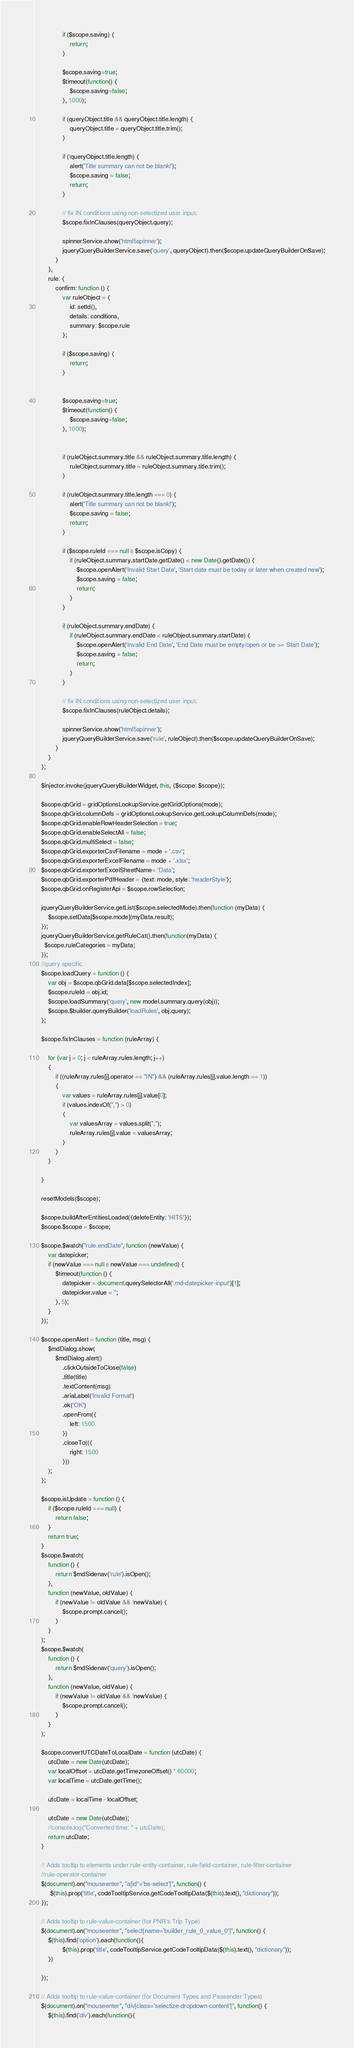<code> <loc_0><loc_0><loc_500><loc_500><_JavaScript_>
                if ($scope.saving) {
                    return;
                }

                $scope.saving=true;
                $timeout(function() {
                    $scope.saving=false;
                }, 1000);
               
                if (queryObject.title && queryObject.title.length) {
                    queryObject.title = queryObject.title.trim();
                }

                if (!queryObject.title.length) {
                    alert('Title summary can not be blank!');
                    $scope.saving = false;
                    return;
                }
                
                // fix IN conditions using non-selectized user input.
                $scope.fixInClauses(queryObject.query);

                spinnerService.show('html5spinner');
                jqueryQueryBuilderService.save('query', queryObject).then($scope.updateQueryBuilderOnSave);
            }
        },
        rule: {
            confirm: function () {
                var ruleObject = {
                    id: setId(),
                    details: conditions,
                    summary: $scope.rule
                };

                if ($scope.saving) {
                    return;
                }
                
              
                $scope.saving=true;
                $timeout(function() {
                    $scope.saving=false;
                }, 1000);


                if (ruleObject.summary.title && ruleObject.summary.title.length) {
                    ruleObject.summary.title = ruleObject.summary.title.trim();
                }

                if (ruleObject.summary.title.length === 0) {
                    alert('Title summary can not be blank!');
                    $scope.saving = false;
                    return;
                }

                if ($scope.ruleId === null || $scope.isCopy) {
                    if (ruleObject.summary.startDate.getDate() < new Date().getDate()) {
                        $scope.openAlert('Invalid Start Date', 'Start date must be today or later when created new');
                        $scope.saving = false;
                        return;
                    }
                }

                if (ruleObject.summary.endDate) {
                    if (ruleObject.summary.endDate < ruleObject.summary.startDate) {
                        $scope.openAlert('Invalid End Date', 'End Date must be empty/open or be >= Start Date');
                        $scope.saving = false;
                        return;
                    }
                }
                
                // fix IN conditions using non-selectized user input.
                $scope.fixInClauses(ruleObject.details);
 
                spinnerService.show('html5spinner');
                jqueryQueryBuilderService.save('rule', ruleObject).then($scope.updateQueryBuilderOnSave);
            }
        }
    };

    $injector.invoke(jqueryQueryBuilderWidget, this, {$scope: $scope});

    $scope.qbGrid = gridOptionsLookupService.getGridOptions(mode);
    $scope.qbGrid.columnDefs = gridOptionsLookupService.getLookupColumnDefs(mode);
    $scope.qbGrid.enableRowHeaderSelection = true;
    $scope.qbGrid.enableSelectAll = false;
    $scope.qbGrid.multiSelect = false;
    $scope.qbGrid.exporterCsvFilename = mode + '.csv';
    $scope.qbGrid.exporterExcelFilename = mode + '.xlsx';
    $scope.qbGrid.exporterExcelSheetName= 'Data';
    $scope.qbGrid.exporterPdfHeader = {text: mode, style: 'headerStyle'};
    $scope.qbGrid.onRegisterApi = $scope.rowSelection;

    jqueryQueryBuilderService.getList($scope.selectedMode).then(function (myData) {
        $scope.setData[$scope.mode](myData.result);
    });
    jqueryQueryBuilderService.getRuleCat().then(function(myData) {
      $scope.ruleCategories = myData;
    });
    //query specific
    $scope.loadQuery = function () {
        var obj = $scope.qbGrid.data[$scope.selectedIndex];
        $scope.ruleId = obj.id;
        $scope.loadSummary('query', new model.summary.query(obj));
        $scope.$builder.queryBuilder('loadRules', obj.query);
    };
    
    $scope.fixInClauses = function (ruleArray) {
        
        for (var j = 0; j < ruleArray.rules.length; j++)
        {
            if ((ruleArray.rules[j].operator == "IN") && (ruleArray.rules[j].value.length == 1))
            {
                var values = ruleArray.rules[j].value[0];
                if (values.indexOf(",") > 0)
                {
                    var valuesArray = values.split(",");
                    ruleArray.rules[j].value = valuesArray;
                }
            }
        }       
        
    }
    
    resetModels($scope);

    $scope.buildAfterEntitiesLoaded({deleteEntity: 'HITS'});
    $scope.$scope = $scope;

    $scope.$watch("rule.endDate", function (newValue) {
        var datepicker;
        if (newValue === null || newValue === undefined) {
            $timeout(function () {
                datepicker = document.querySelectorAll('.md-datepicker-input')[1];
                datepicker.value = '';
            }, 5);
        }
    });

    $scope.openAlert = function (title, msg) {
        $mdDialog.show(
            $mdDialog.alert()
                .clickOutsideToClose(false)
                .title(title)
                .textContent(msg)
                .ariaLabel('Invalid Format')
                .ok('OK')
                .openFrom({
                    left: 1500
                })
                .closeTo(({
                    right: 1500
                }))
        );
    };

    $scope.isUpdate = function () {
        if ($scope.ruleId === null) {
            return false;
        }
        return true;
    }
    $scope.$watch(
        function () {
            return $mdSidenav('rule').isOpen();
        },
        function (newValue, oldValue) {
            if (newValue != oldValue && !newValue) {
                $scope.prompt.cancel();
            }
        }
    );
    $scope.$watch(
        function () {
            return $mdSidenav('query').isOpen();
        },
        function (newValue, oldValue) {
            if (newValue != oldValue && !newValue) {
                $scope.prompt.cancel();
            }
        }
    );
    
    $scope.convertUTCDateToLocalDate = function (utcDate) {
        utcDate = new Date(utcDate);
        var localOffset = utcDate.getTimezoneOffset() * 60000;
        var localTime = utcDate.getTime();

        utcDate = localTime - localOffset;

        utcDate = new Date(utcDate);
        //console.log("Converted time: " + utcDate);
        return utcDate;
	}
	
	// Adds tooltip to elements under rule-entity-container, rule-field-container, rule-filter-container
	//rule-operator-container
	$(document).on("mouseenter", "a[id*='bs-select']", function() {
		 $(this).prop('title', codeTooltipService.getCodeTooltipData($(this).text(), "dictionary"));
	});

	// Adds tooltip to rule-value-container (for PNR's Trip Type)
	$(document).on("mouseenter", "select[name='builder_rule_0_value_0']", function() {
		$(this).find('option').each(function(){
				$(this).prop('title', codeTooltipService.getCodeTooltipData($(this).text(), "dictionary"));
		})
		 
	});

	// Adds tooltip to rule-value-container (for Document Types and Passender Types)
	$(document).on("mouseenter", "div[class='selectize-dropdown-content']", function() {
		$(this).find('div').each(function(){</code> 